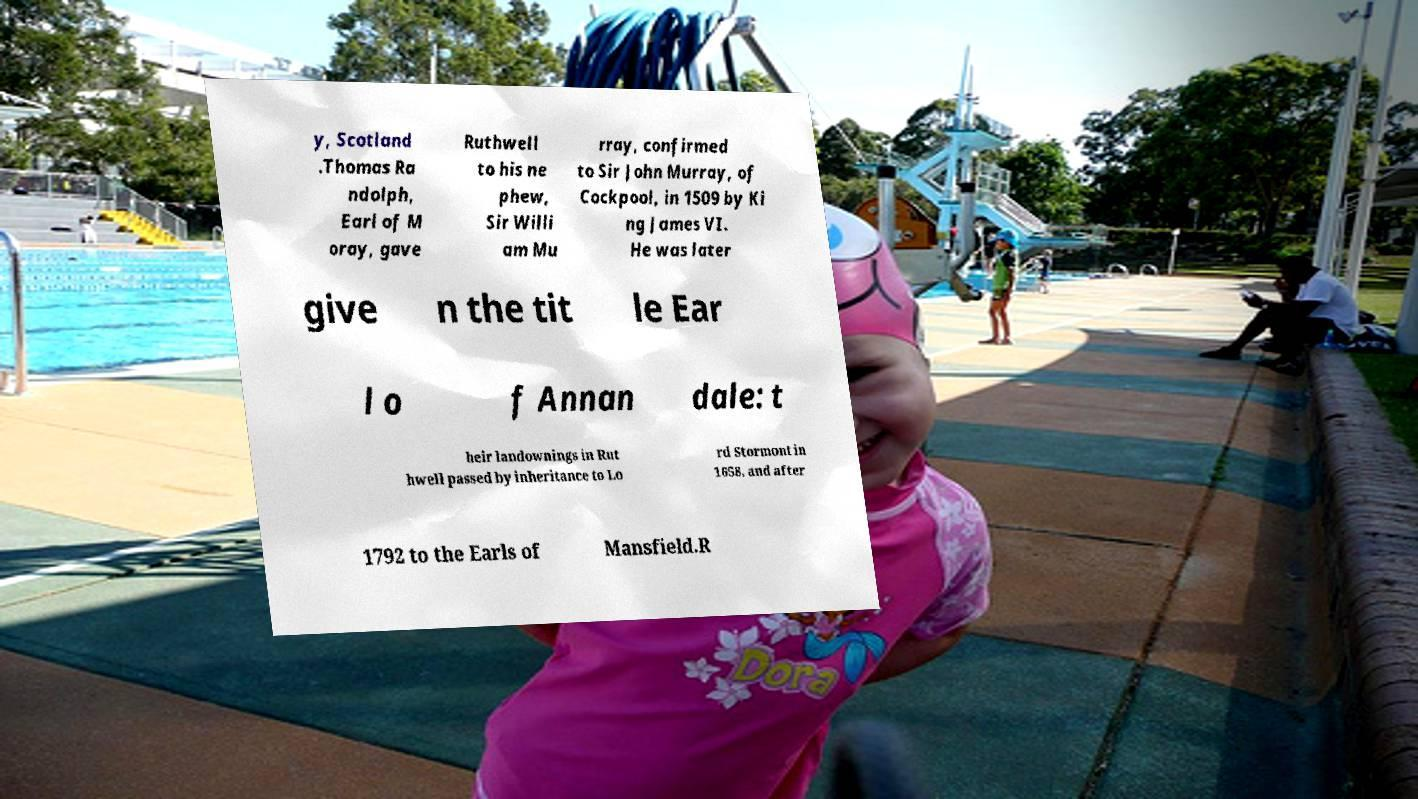I need the written content from this picture converted into text. Can you do that? y, Scotland .Thomas Ra ndolph, Earl of M oray, gave Ruthwell to his ne phew, Sir Willi am Mu rray, confirmed to Sir John Murray, of Cockpool, in 1509 by Ki ng James VI. He was later give n the tit le Ear l o f Annan dale: t heir landownings in Rut hwell passed by inheritance to Lo rd Stormont in 1658, and after 1792 to the Earls of Mansfield.R 